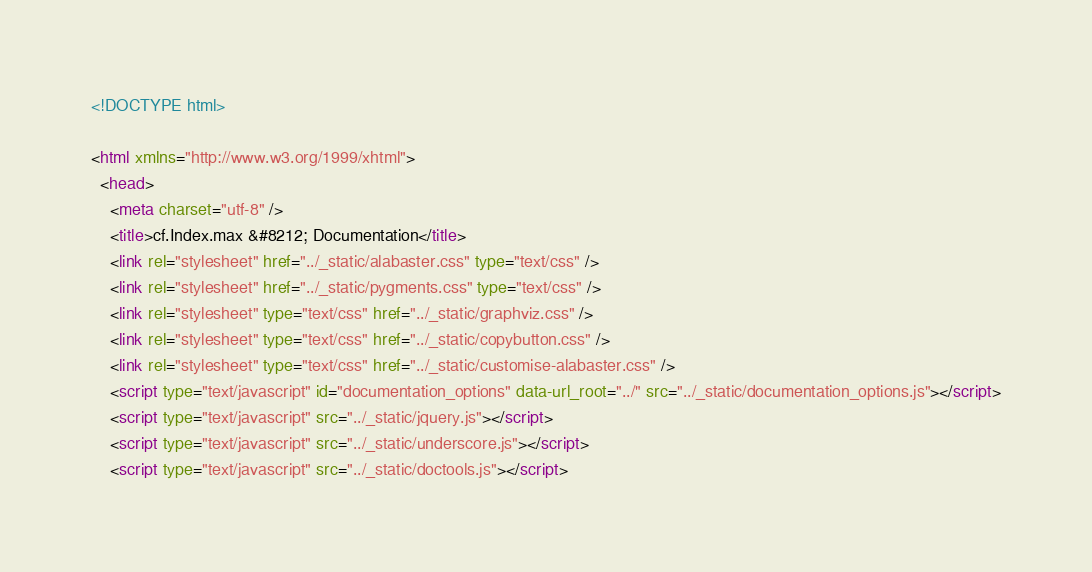<code> <loc_0><loc_0><loc_500><loc_500><_HTML_>
<!DOCTYPE html>

<html xmlns="http://www.w3.org/1999/xhtml">
  <head>
    <meta charset="utf-8" />
    <title>cf.Index.max &#8212; Documentation</title>
    <link rel="stylesheet" href="../_static/alabaster.css" type="text/css" />
    <link rel="stylesheet" href="../_static/pygments.css" type="text/css" />
    <link rel="stylesheet" type="text/css" href="../_static/graphviz.css" />
    <link rel="stylesheet" type="text/css" href="../_static/copybutton.css" />
    <link rel="stylesheet" type="text/css" href="../_static/customise-alabaster.css" />
    <script type="text/javascript" id="documentation_options" data-url_root="../" src="../_static/documentation_options.js"></script>
    <script type="text/javascript" src="../_static/jquery.js"></script>
    <script type="text/javascript" src="../_static/underscore.js"></script>
    <script type="text/javascript" src="../_static/doctools.js"></script></code> 